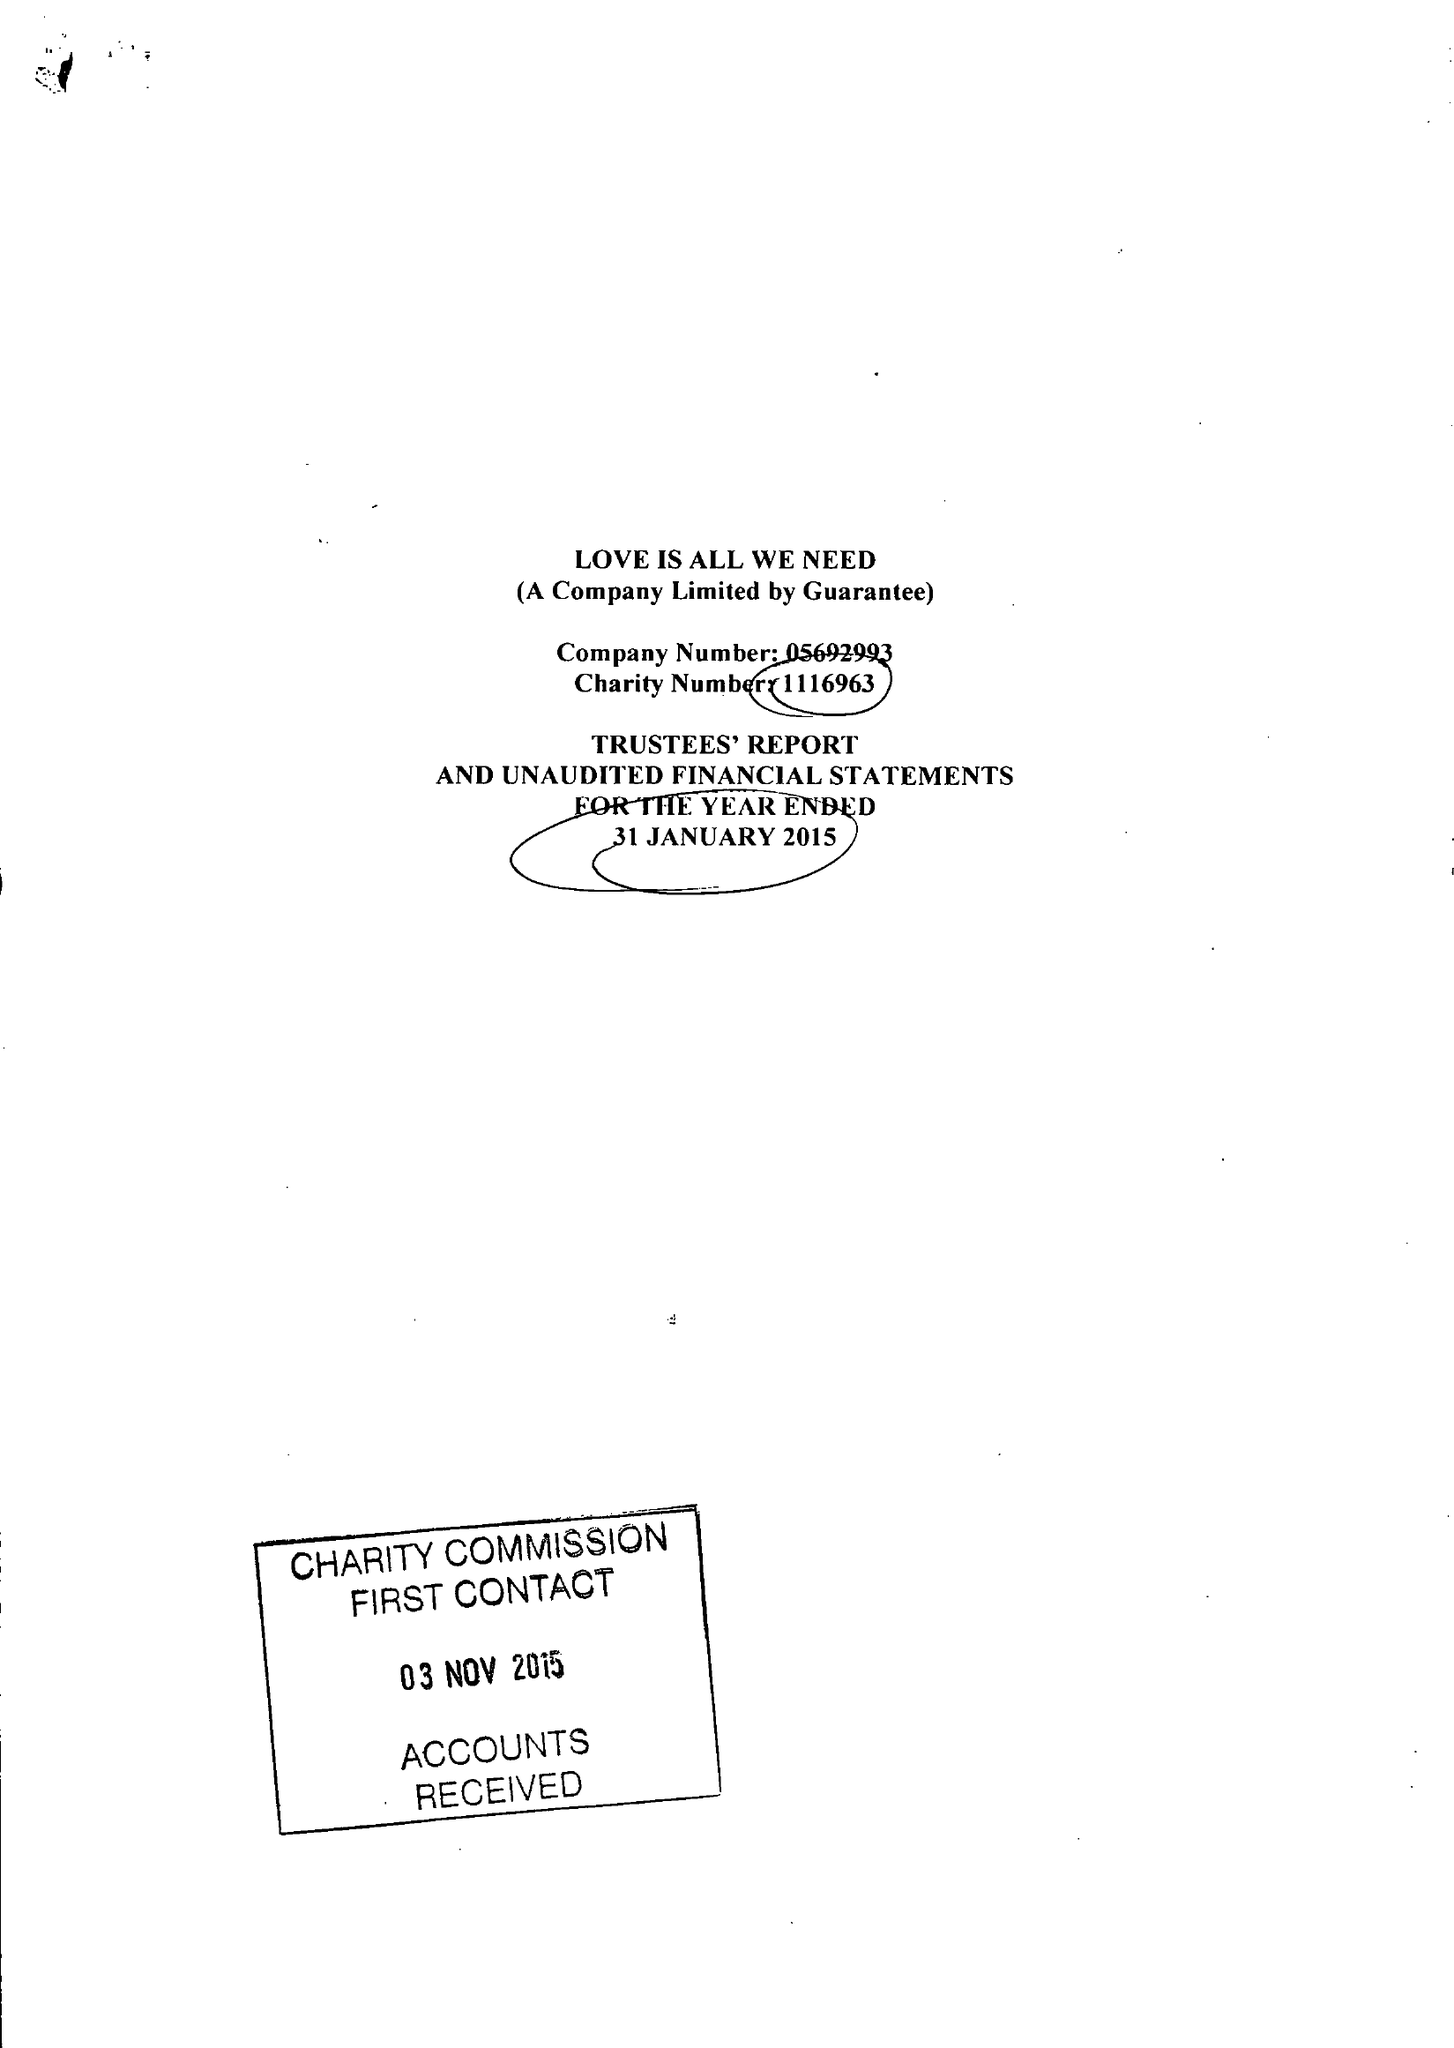What is the value for the spending_annually_in_british_pounds?
Answer the question using a single word or phrase. 30881.00 